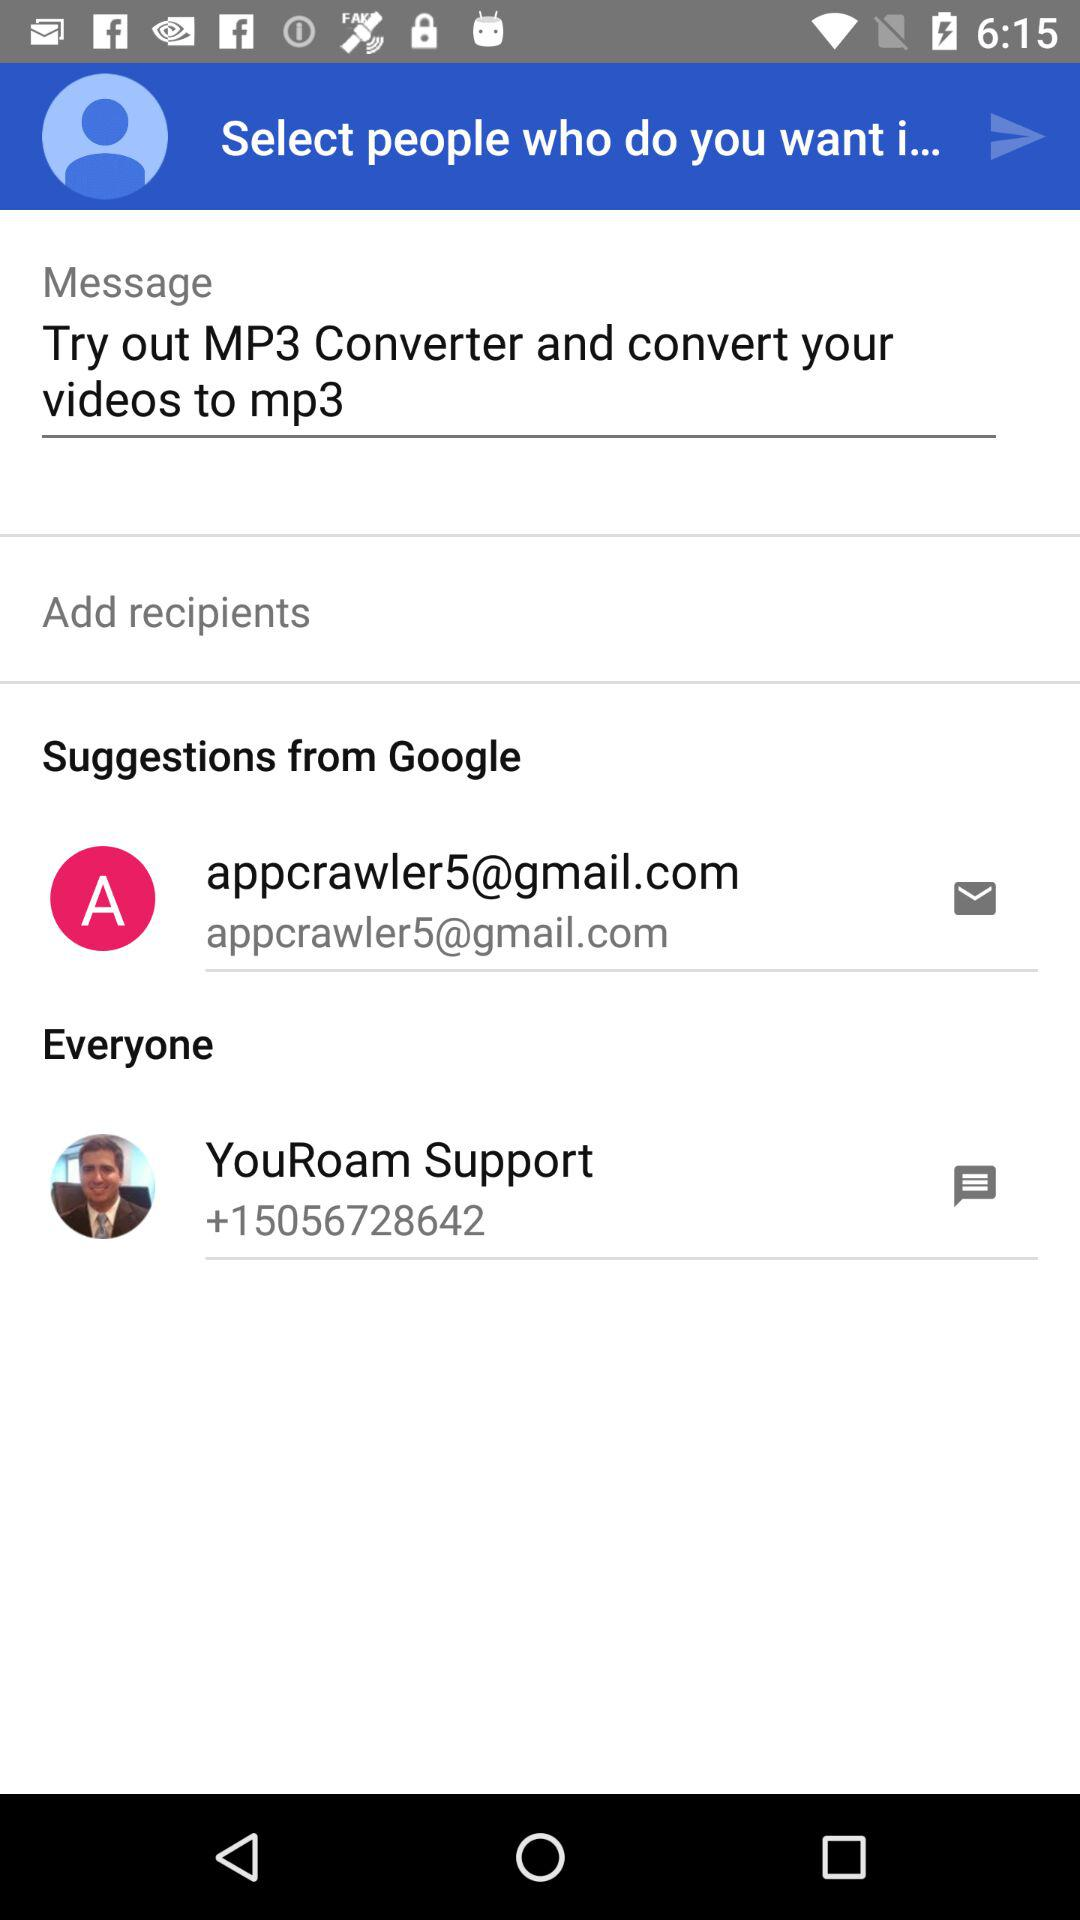When was "YouRoam Support" added?
When the provided information is insufficient, respond with <no answer>. <no answer> 